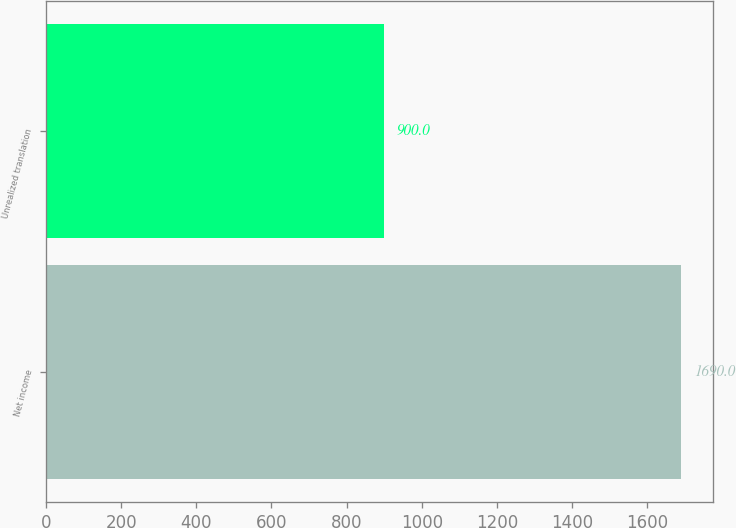Convert chart to OTSL. <chart><loc_0><loc_0><loc_500><loc_500><bar_chart><fcel>Net income<fcel>Unrealized translation<nl><fcel>1690<fcel>900<nl></chart> 